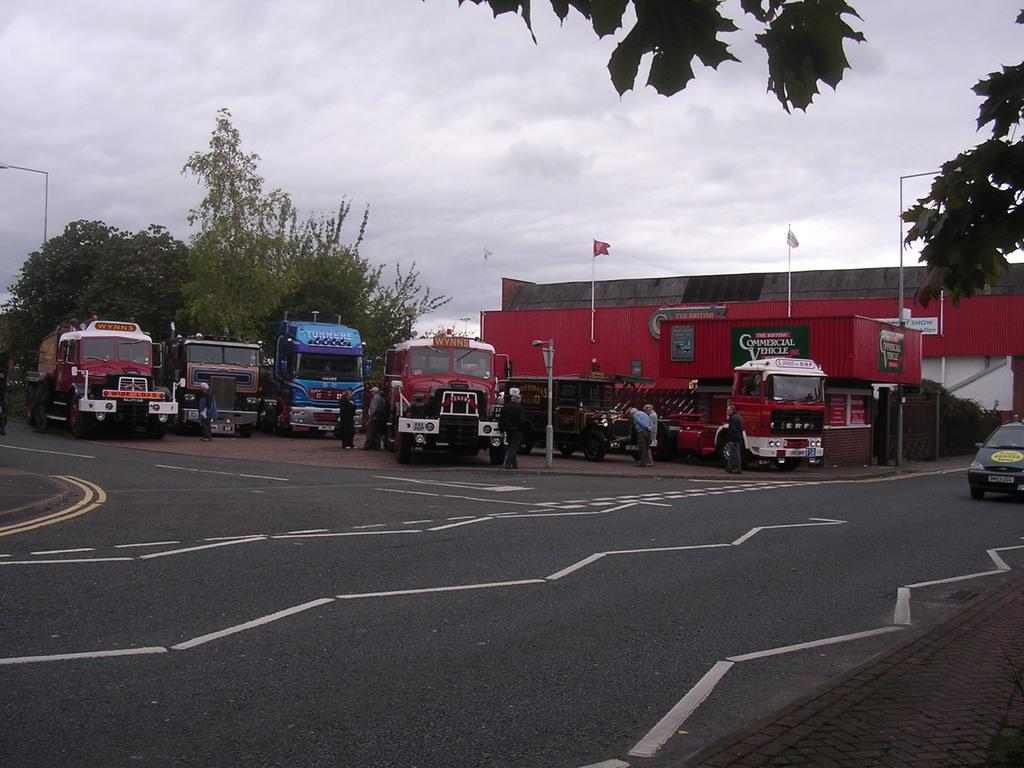What is the main subject of the image? There is a vehicle on the road in the image. Can you describe the surroundings of the vehicle? In the background of the image, there are many vehicles, people, poles, a shed, and trees. What part of the natural environment is visible in the image? The sky is visible in the image. What type of plate is being used to serve the food in the image? There is no food or plate present in the image; it features a vehicle on the road and various elements in the background. 